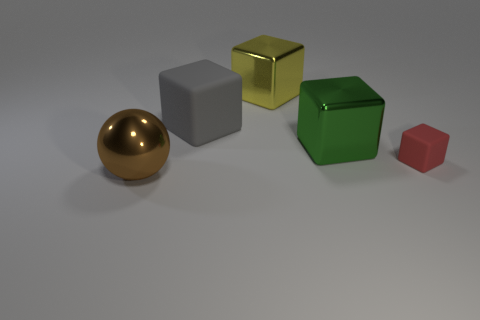There is a object on the left side of the rubber cube behind the tiny red thing; what is it made of?
Make the answer very short. Metal. Is the number of metal things to the right of the small red cube less than the number of metal cubes to the left of the big green shiny thing?
Make the answer very short. Yes. How many gray objects are big matte things or tiny matte cylinders?
Offer a very short reply. 1. Are there an equal number of gray cubes that are left of the green shiny block and big green blocks?
Give a very brief answer. Yes. What number of objects are either big blue things or matte blocks in front of the large gray object?
Ensure brevity in your answer.  1. Do the metal ball and the large matte object have the same color?
Provide a succinct answer. No. Is there another brown sphere that has the same material as the brown ball?
Give a very brief answer. No. There is another tiny object that is the same shape as the yellow thing; what is its color?
Keep it short and to the point. Red. Are the large yellow object and the big object that is in front of the large green cube made of the same material?
Provide a succinct answer. Yes. The big object that is on the left side of the rubber thing behind the tiny red block is what shape?
Your answer should be very brief. Sphere. 